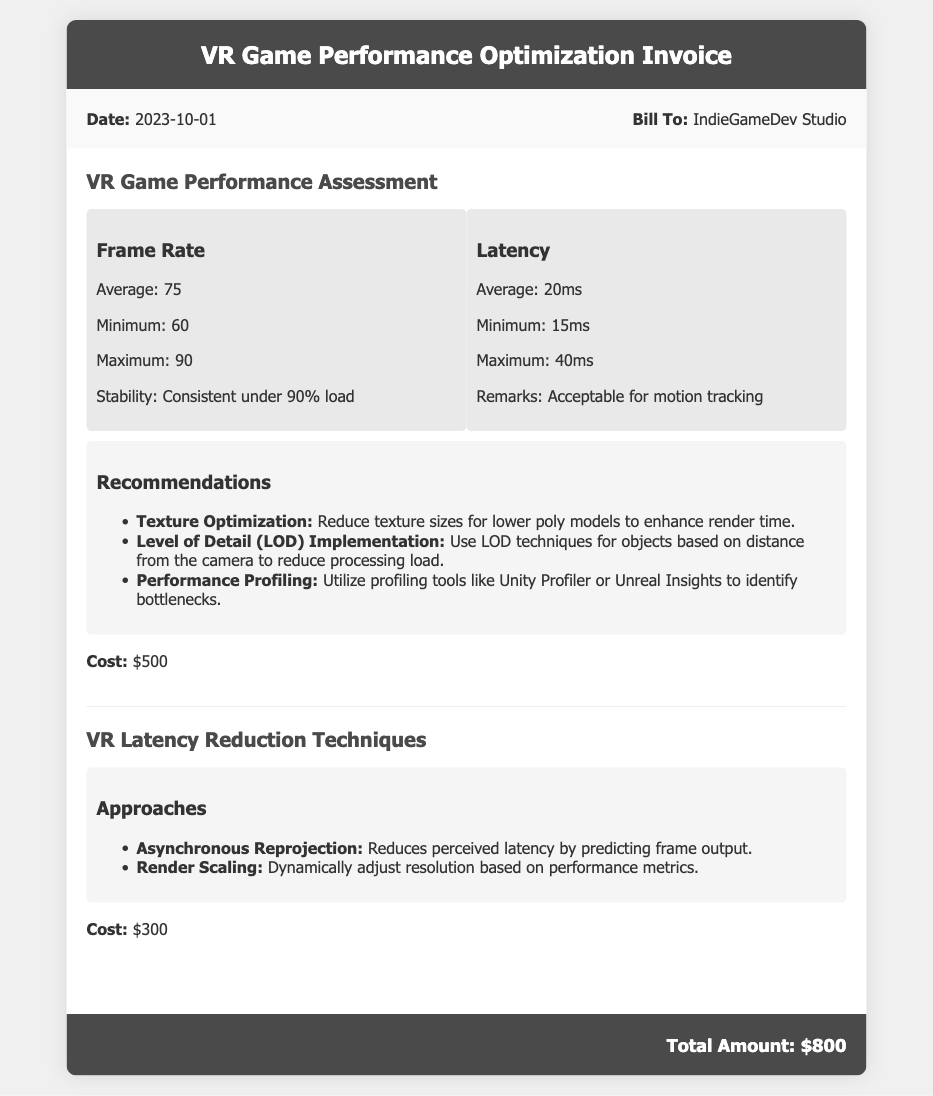what is the date of the invoice? The date of the invoice is clearly stated in the document as 2023-10-01.
Answer: 2023-10-01 who is the bill addressed to? The document specifies that the bill is addressed to IndieGameDev Studio.
Answer: IndieGameDev Studio what is the average frame rate reported? The document indicates that the average frame rate is 75.
Answer: 75 what is the cost of the VR Game Performance Assessment? The cost for the VR Game Performance Assessment is listed as $500.
Answer: $500 what is the maximum latency recorded? The maximum latency stated in the document is 40ms.
Answer: 40ms how many recommendations are provided for performance optimization? The document lists three recommendations for performance optimization.
Answer: three what is the total amount due for the bill? The document summarizes the total amount due at the bottom as $800.
Answer: $800 what approach is suggested for reducing perceived latency? The document suggests Asynchronous Reprojection as an approach for reducing perceived latency.
Answer: Asynchronous Reprojection which performance profiling tool is mentioned in the recommendations? The document specifically mentions Unity Profiler as a profiling tool to use.
Answer: Unity Profiler 